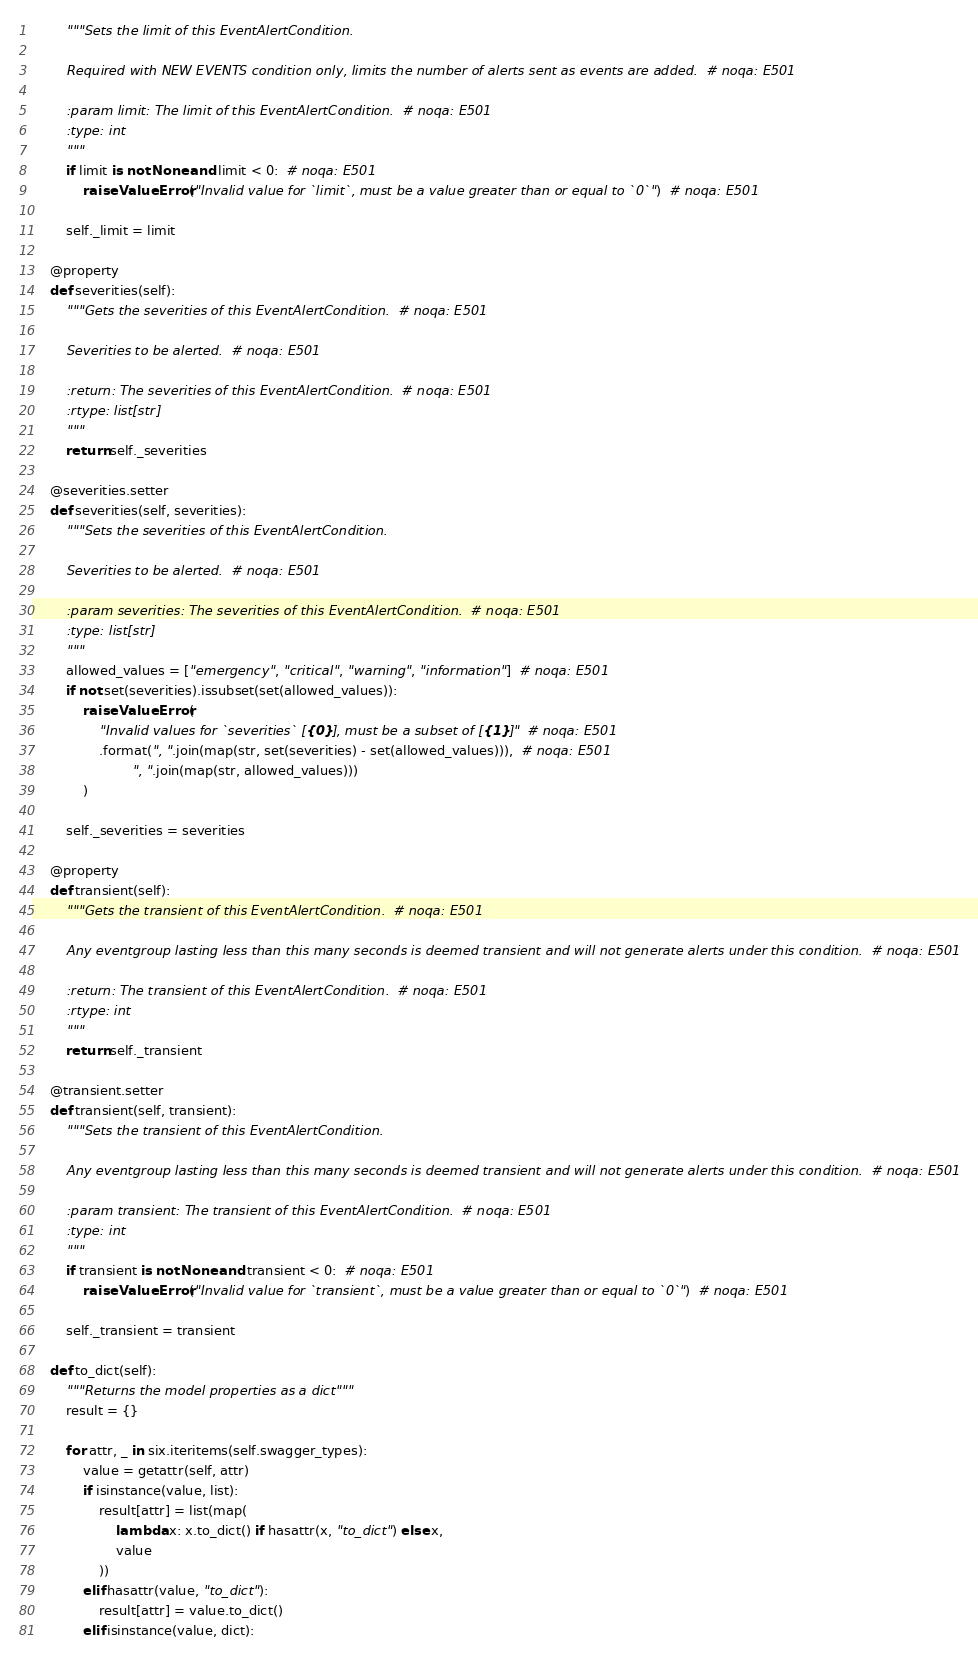Convert code to text. <code><loc_0><loc_0><loc_500><loc_500><_Python_>        """Sets the limit of this EventAlertCondition.

        Required with NEW EVENTS condition only, limits the number of alerts sent as events are added.  # noqa: E501

        :param limit: The limit of this EventAlertCondition.  # noqa: E501
        :type: int
        """
        if limit is not None and limit < 0:  # noqa: E501
            raise ValueError("Invalid value for `limit`, must be a value greater than or equal to `0`")  # noqa: E501

        self._limit = limit

    @property
    def severities(self):
        """Gets the severities of this EventAlertCondition.  # noqa: E501

        Severities to be alerted.  # noqa: E501

        :return: The severities of this EventAlertCondition.  # noqa: E501
        :rtype: list[str]
        """
        return self._severities

    @severities.setter
    def severities(self, severities):
        """Sets the severities of this EventAlertCondition.

        Severities to be alerted.  # noqa: E501

        :param severities: The severities of this EventAlertCondition.  # noqa: E501
        :type: list[str]
        """
        allowed_values = ["emergency", "critical", "warning", "information"]  # noqa: E501
        if not set(severities).issubset(set(allowed_values)):
            raise ValueError(
                "Invalid values for `severities` [{0}], must be a subset of [{1}]"  # noqa: E501
                .format(", ".join(map(str, set(severities) - set(allowed_values))),  # noqa: E501
                        ", ".join(map(str, allowed_values)))
            )

        self._severities = severities

    @property
    def transient(self):
        """Gets the transient of this EventAlertCondition.  # noqa: E501

        Any eventgroup lasting less than this many seconds is deemed transient and will not generate alerts under this condition.  # noqa: E501

        :return: The transient of this EventAlertCondition.  # noqa: E501
        :rtype: int
        """
        return self._transient

    @transient.setter
    def transient(self, transient):
        """Sets the transient of this EventAlertCondition.

        Any eventgroup lasting less than this many seconds is deemed transient and will not generate alerts under this condition.  # noqa: E501

        :param transient: The transient of this EventAlertCondition.  # noqa: E501
        :type: int
        """
        if transient is not None and transient < 0:  # noqa: E501
            raise ValueError("Invalid value for `transient`, must be a value greater than or equal to `0`")  # noqa: E501

        self._transient = transient

    def to_dict(self):
        """Returns the model properties as a dict"""
        result = {}

        for attr, _ in six.iteritems(self.swagger_types):
            value = getattr(self, attr)
            if isinstance(value, list):
                result[attr] = list(map(
                    lambda x: x.to_dict() if hasattr(x, "to_dict") else x,
                    value
                ))
            elif hasattr(value, "to_dict"):
                result[attr] = value.to_dict()
            elif isinstance(value, dict):</code> 